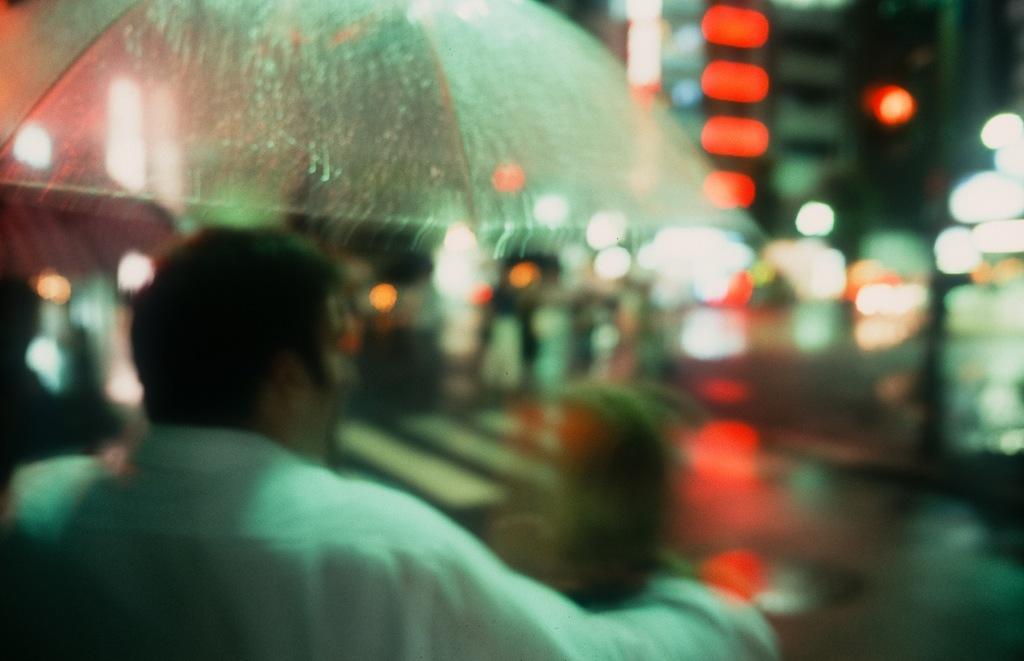Could you give a brief overview of what you see in this image? The picture is blurred. In the foreground of the picture there is a man holding an umbrella. It is raining. In the background there are lights. 